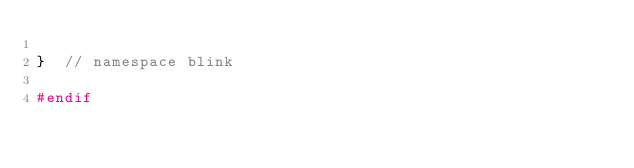Convert code to text. <code><loc_0><loc_0><loc_500><loc_500><_C_>
}  // namespace blink

#endif
</code> 